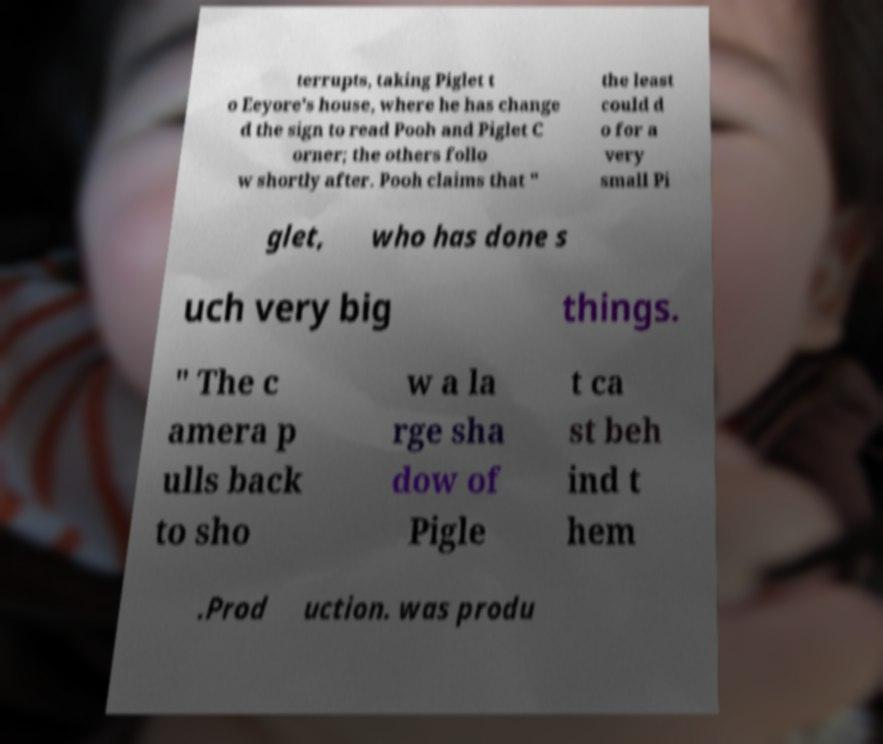Please identify and transcribe the text found in this image. terrupts, taking Piglet t o Eeyore's house, where he has change d the sign to read Pooh and Piglet C orner; the others follo w shortly after. Pooh claims that " the least could d o for a very small Pi glet, who has done s uch very big things. " The c amera p ulls back to sho w a la rge sha dow of Pigle t ca st beh ind t hem .Prod uction. was produ 